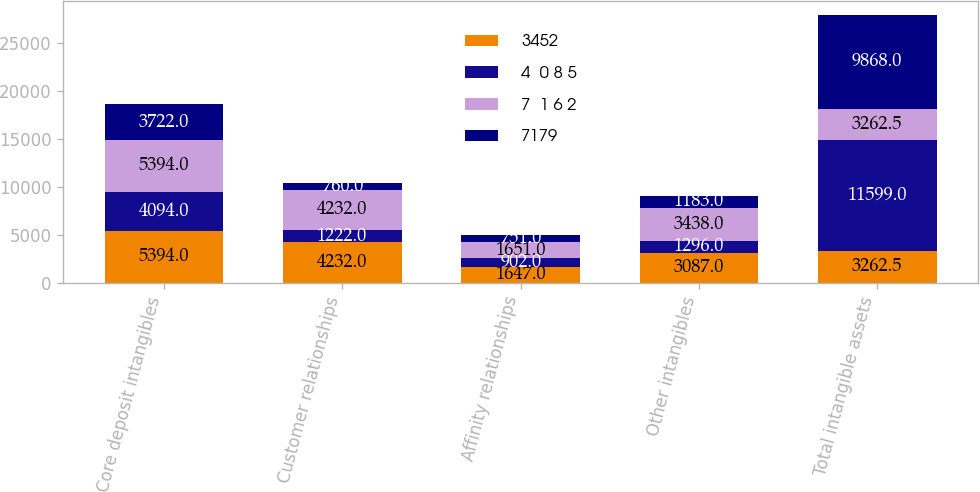Convert chart to OTSL. <chart><loc_0><loc_0><loc_500><loc_500><stacked_bar_chart><ecel><fcel>Core deposit intangibles<fcel>Customer relationships<fcel>Affinity relationships<fcel>Other intangibles<fcel>Total intangible assets<nl><fcel>3452<fcel>5394<fcel>4232<fcel>1647<fcel>3087<fcel>3262.5<nl><fcel>4  0 8 5<fcel>4094<fcel>1222<fcel>902<fcel>1296<fcel>11599<nl><fcel>7  1 6 2<fcel>5394<fcel>4232<fcel>1651<fcel>3438<fcel>3262.5<nl><fcel>7179<fcel>3722<fcel>760<fcel>751<fcel>1183<fcel>9868<nl></chart> 